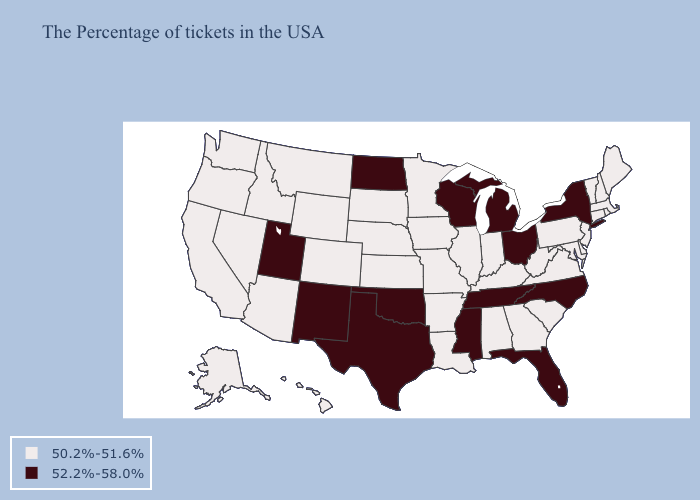Among the states that border Georgia , does Alabama have the highest value?
Keep it brief. No. What is the lowest value in the West?
Give a very brief answer. 50.2%-51.6%. Name the states that have a value in the range 50.2%-51.6%?
Keep it brief. Maine, Massachusetts, Rhode Island, New Hampshire, Vermont, Connecticut, New Jersey, Delaware, Maryland, Pennsylvania, Virginia, South Carolina, West Virginia, Georgia, Kentucky, Indiana, Alabama, Illinois, Louisiana, Missouri, Arkansas, Minnesota, Iowa, Kansas, Nebraska, South Dakota, Wyoming, Colorado, Montana, Arizona, Idaho, Nevada, California, Washington, Oregon, Alaska, Hawaii. Among the states that border Utah , does Nevada have the highest value?
Quick response, please. No. What is the value of Illinois?
Write a very short answer. 50.2%-51.6%. Name the states that have a value in the range 52.2%-58.0%?
Short answer required. New York, North Carolina, Ohio, Florida, Michigan, Tennessee, Wisconsin, Mississippi, Oklahoma, Texas, North Dakota, New Mexico, Utah. What is the highest value in states that border Massachusetts?
Concise answer only. 52.2%-58.0%. Name the states that have a value in the range 52.2%-58.0%?
Quick response, please. New York, North Carolina, Ohio, Florida, Michigan, Tennessee, Wisconsin, Mississippi, Oklahoma, Texas, North Dakota, New Mexico, Utah. Among the states that border Kentucky , does Tennessee have the highest value?
Give a very brief answer. Yes. Name the states that have a value in the range 50.2%-51.6%?
Quick response, please. Maine, Massachusetts, Rhode Island, New Hampshire, Vermont, Connecticut, New Jersey, Delaware, Maryland, Pennsylvania, Virginia, South Carolina, West Virginia, Georgia, Kentucky, Indiana, Alabama, Illinois, Louisiana, Missouri, Arkansas, Minnesota, Iowa, Kansas, Nebraska, South Dakota, Wyoming, Colorado, Montana, Arizona, Idaho, Nevada, California, Washington, Oregon, Alaska, Hawaii. What is the value of Georgia?
Concise answer only. 50.2%-51.6%. What is the highest value in the USA?
Give a very brief answer. 52.2%-58.0%. Does Mississippi have the same value as New Jersey?
Quick response, please. No. What is the value of Colorado?
Short answer required. 50.2%-51.6%. 